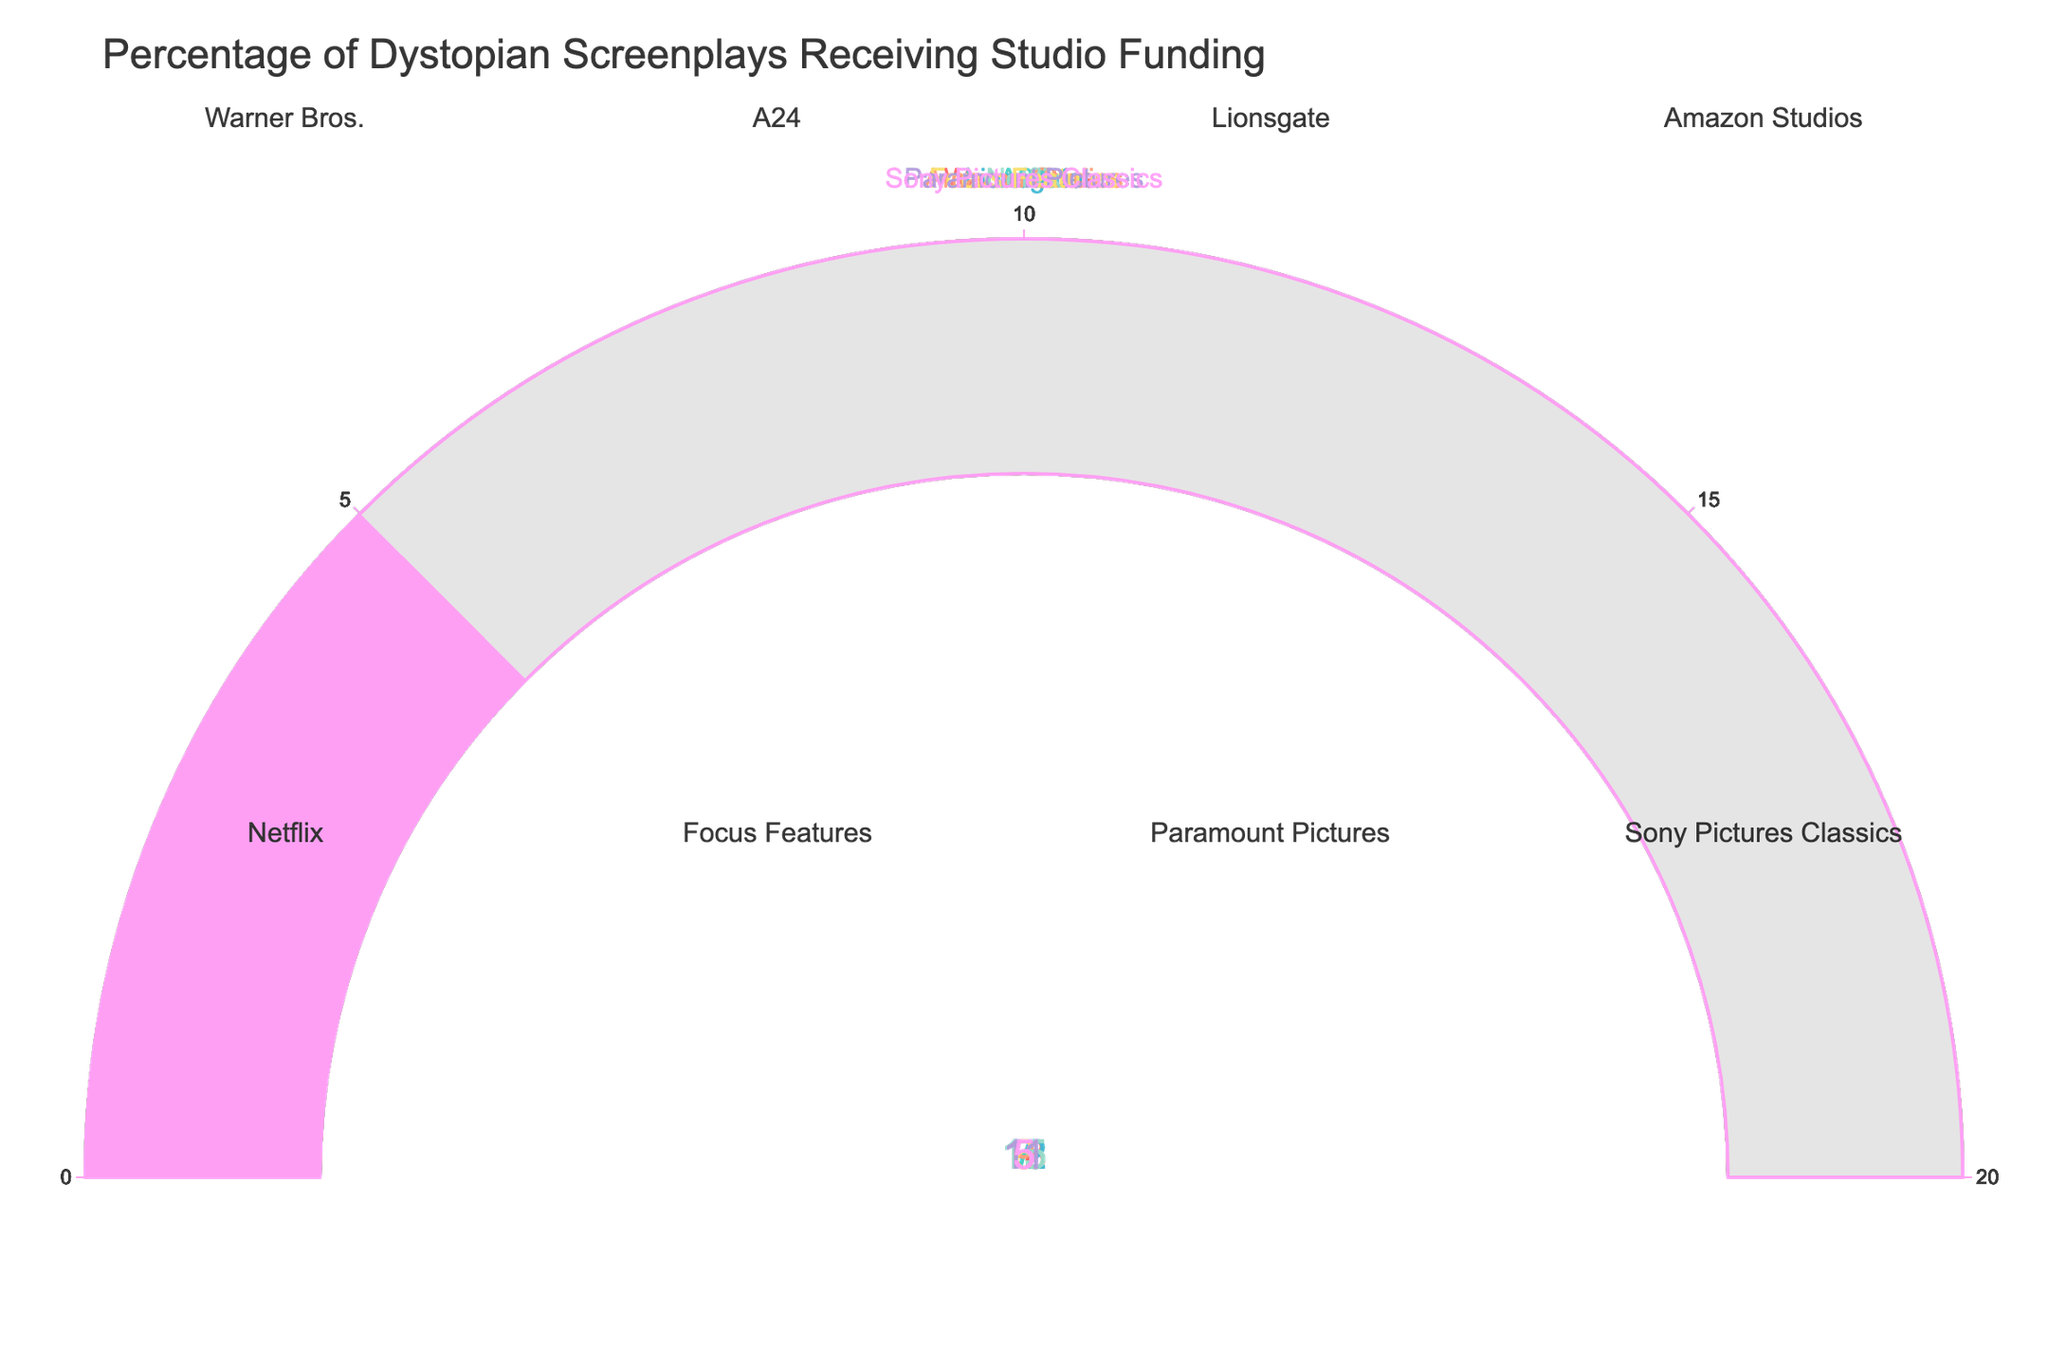What's the title of the chart? The title is typically displayed prominently at the top of the chart. Here it reads "Percentage of Dystopian Screenplays Receiving Studio Funding".
Answer: Percentage of Dystopian Screenplays Receiving Studio Funding How many studios are shown in the gauge chart? Count the number of individual gauge sections or the number of subplot titles; there are 8 studios represented.
Answer: 8 Which studio has the highest percentage of funding? Compare the values displayed on each gauge. Warner Bros. has the highest percentage of funding at 18%.
Answer: Warner Bros Which studio has the lowest percentage of funding? Compare the values displayed on each gauge. Sony Pictures Classics has the lowest percentage of funding at 5%.
Answer: Sony Pictures Classics What is the average funding percentage across all studios? Add up all the percentages (18 + 7 + 12 + 9 + 15 + 6 + 11 + 5) and divide by the number of studios (8). The total is 83, so the average is 83 / 8 = 10.375.
Answer: 10.375 What is the difference in funding percentage between Warner Bros. and A24? Subtract A24's percentage (7) from Warner Bros.' percentage (18). 18 - 7 = 11.
Answer: 11 Which studio falls exactly in the middle of funding percentages when sorted? List the percentages in ascending order (5, 6, 7, 9, 11, 12, 15, 18). The middle values are 9 (Amazon Studios) and 11 (Paramount Pictures), thus the combined middle studios.
Answer: Amazon Studios and Paramount Pictures How much higher is Netflix's funding percentage compared to Focus Features' percentage? Subtract Focus Features' percentage (6) from Netflix's percentage (15). 15 - 6 = 9.
Answer: 9 What is the median funding percentage of all the studios? When the percentages are sorted (5, 6, 7, 9, 11, 12, 15, 18), the median is the average of the 4th and 5th values since the number of items is even. Thus, (9 + 11) / 2 = 10.
Answer: 10 